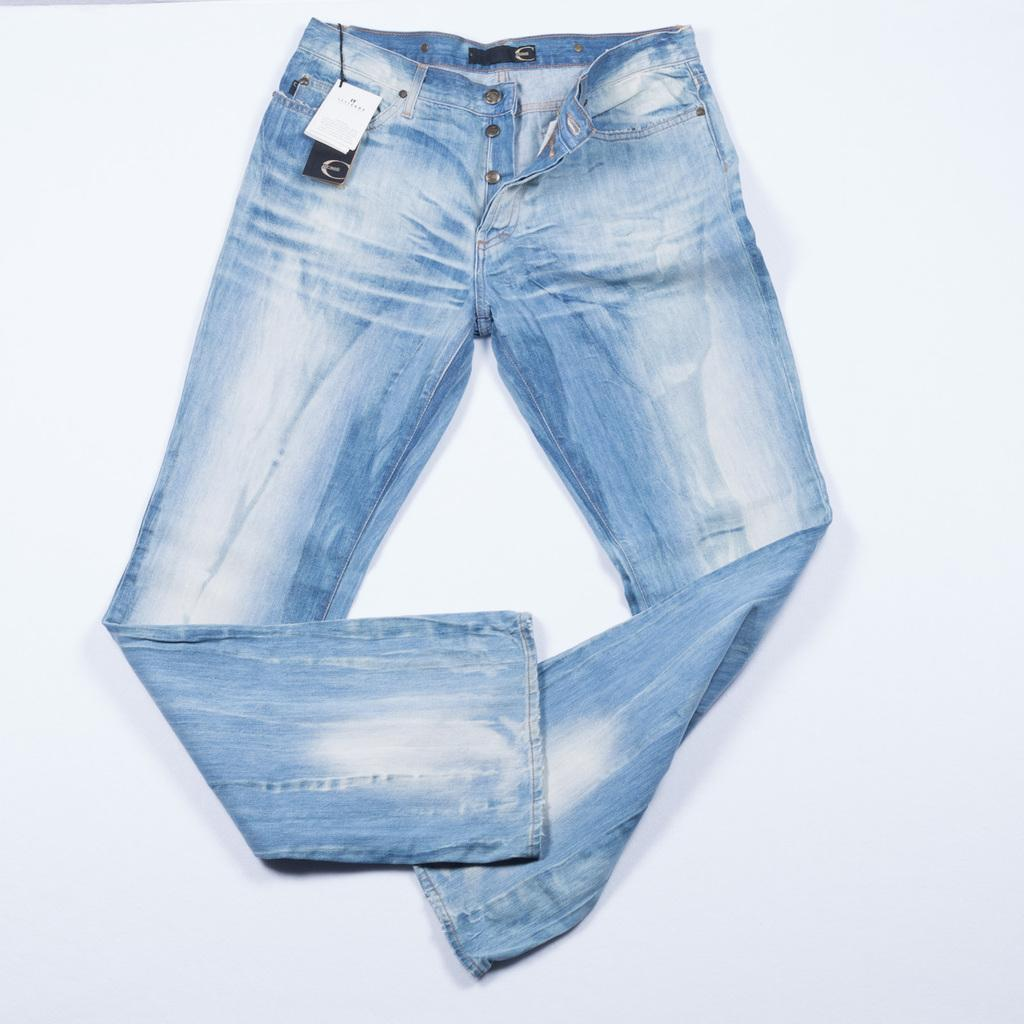What is the main subject in the center of the image? There is a jeans pant in the center of the image. What can be seen in the background of the image? There is a wall in the background of the image. What type of word can be seen written on the jeans pant in the image? There are no words visible on the jeans pant in the image. How does the jeans pant provide a grip for the person wearing it in the image? The jeans pant does not provide a grip for the person wearing it in the image, as it is an inanimate object. 